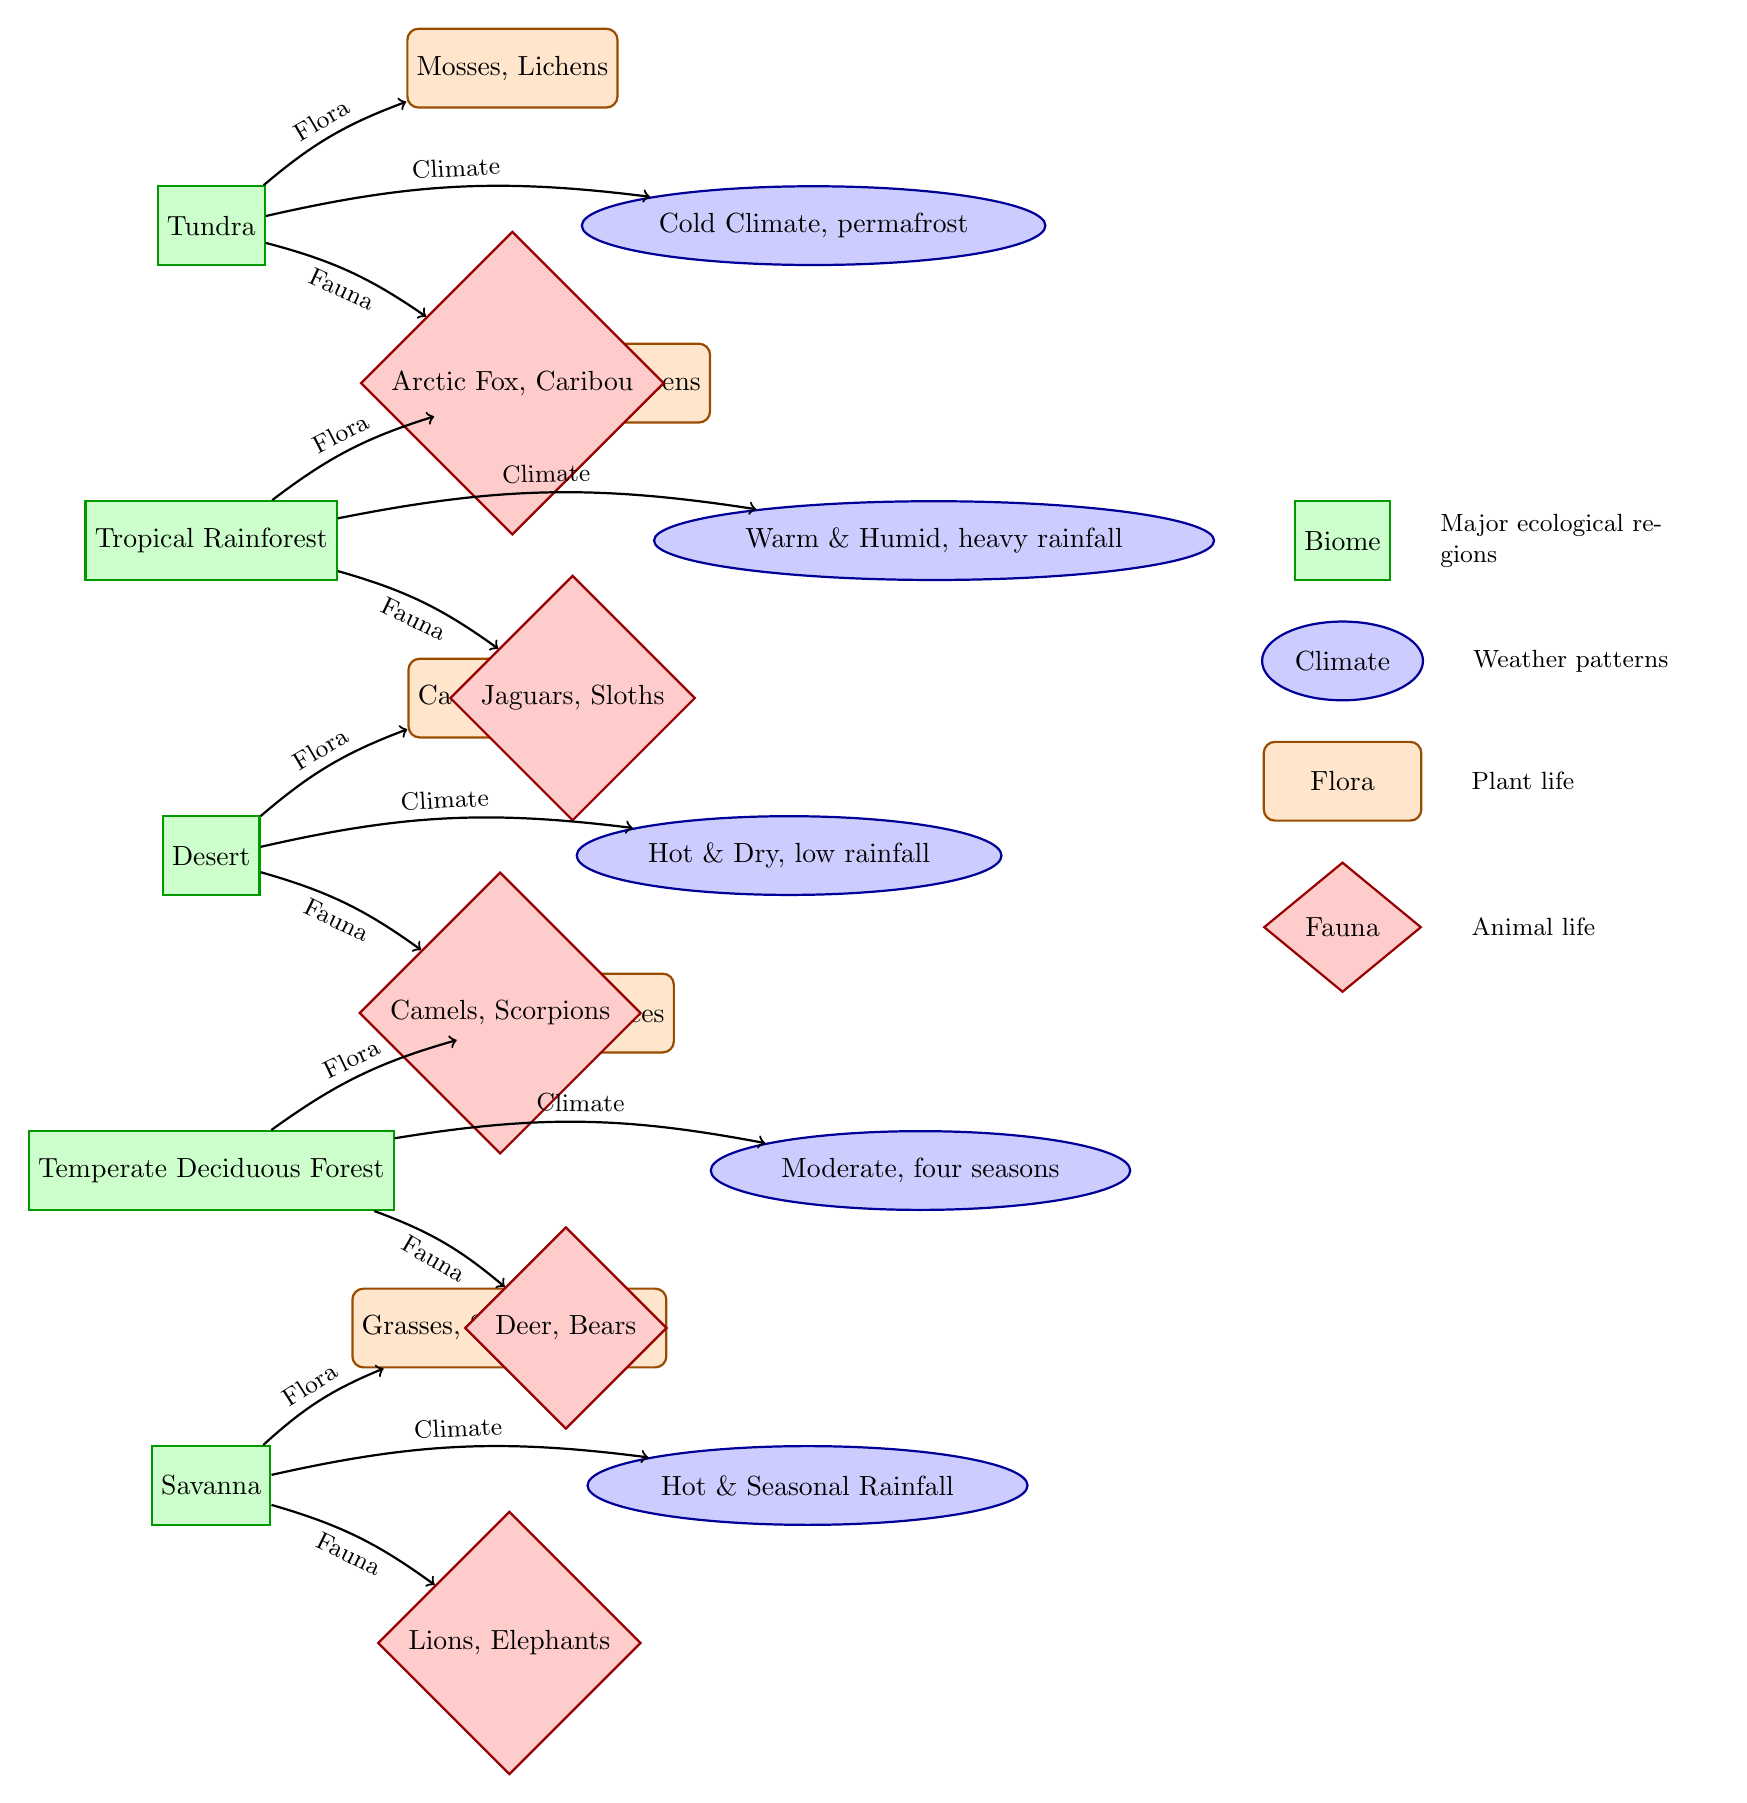What's the climate associated with the Tundra biome? The diagram shows the Tundra biome with an arrow leading to the climate node that states "Cold Climate, permafrost." Thus, the climate for Tundra is explicitly mentioned.
Answer: Cold Climate, permafrost Which flora is found in the Tropical Rainforest? In the diagram, there is a line connecting the Tropical Rainforest biome to its flora node, which contains the text "Broadleaf Evergreens." This indicates the specific plant life found in this biome.
Answer: Broadleaf Evergreens How many biomes are represented in the diagram? By counting the rectangles (biomes) in the diagram, we can see there are a total of five biomes: Tundra, Tropical Rainforest, Desert, Temperate Deciduous Forest, and Savanna.
Answer: 5 What type of fauna is found in the Savanna? The diagram connects the Savanna biome to a diamond-shaped node indicating the fauna, which lists "Lions, Elephants." This directly answers the question about animal life in the Savanna.
Answer: Lions, Elephants What is the climate type that describes the Desert biome? The diagram specifies the climate tied to the Desert biome, which states "Hot & Dry, low rainfall." This node indicates the weather pattern characteristic of the Desert.
Answer: Hot & Dry, low rainfall Which biome has a moderate climate with four seasons? The diagram identifies the Temperate Deciduous Forest biome and shows the corresponding climate node that reads "Moderate, four seasons." Hence, the biome with this climate is clearly marked.
Answer: Temperate Deciduous Forest What connects each biome to its flora and fauna? The arrows in the diagram directly establish connections between each biome and their respective flora and fauna nodes, showing the relationships. Each biome links to one flora and one fauna.
Answer: Arrows What do the rectangular shapes in the diagram represent? The rectangular shapes in the diagram are labeled as "biome," indicating that they represent major ecological regions, as specified in the legend.
Answer: Biome What is the climate of the Savanna biome? The diagram includes a climate node linked to the Savanna biome labeled "Hot & Seasonal Rainfall," which directly answers the query about its climate.
Answer: Hot & Seasonal Rainfall 